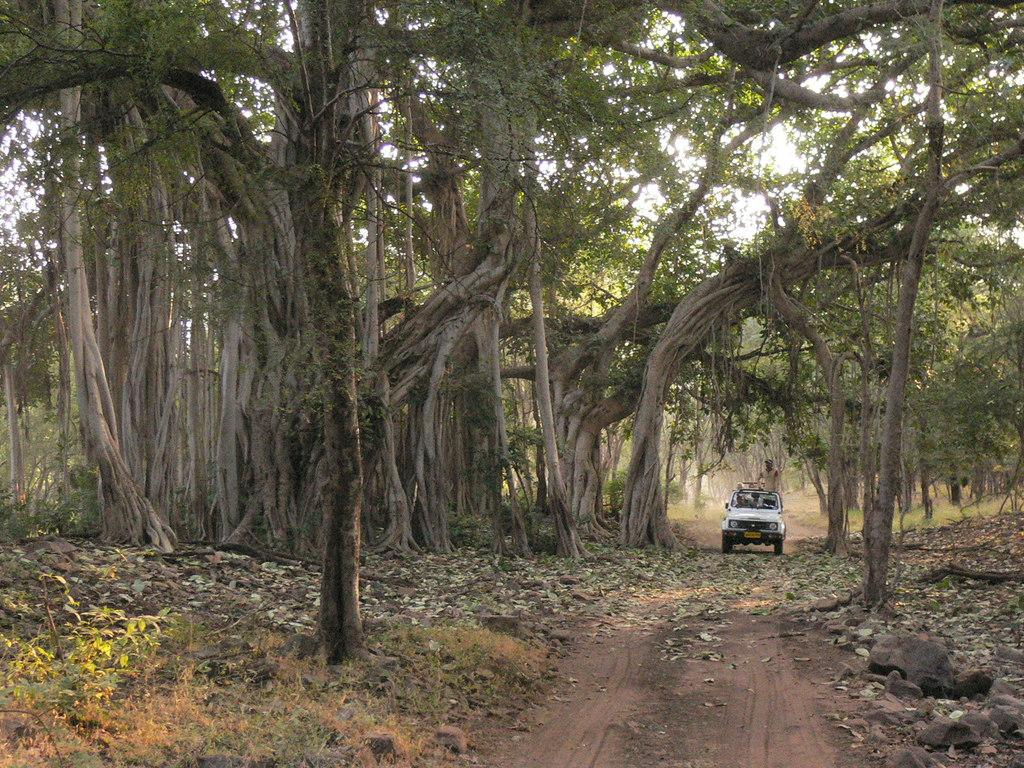What color is the vehicle in the image? The vehicle in the image is white. Can you describe the occupant of the vehicle? There is a person inside the vehicle. What can be seen in the background of the image? There are trees and the sky visible in the background of the image. What is the color of the trees in the image? The trees in the image are green. What is the color of the sky in the image? The sky in the image is white. Can you tell me how many people are swimming in the sea in the image? There is no sea present in the image, so it is not possible to answer that question. 